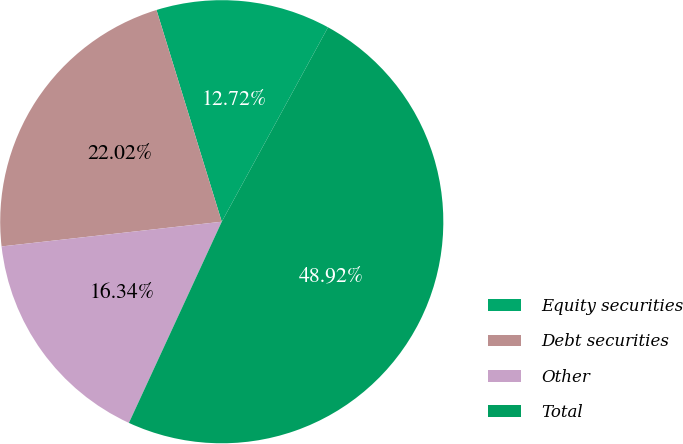Convert chart to OTSL. <chart><loc_0><loc_0><loc_500><loc_500><pie_chart><fcel>Equity securities<fcel>Debt securities<fcel>Other<fcel>Total<nl><fcel>12.72%<fcel>22.02%<fcel>16.34%<fcel>48.92%<nl></chart> 